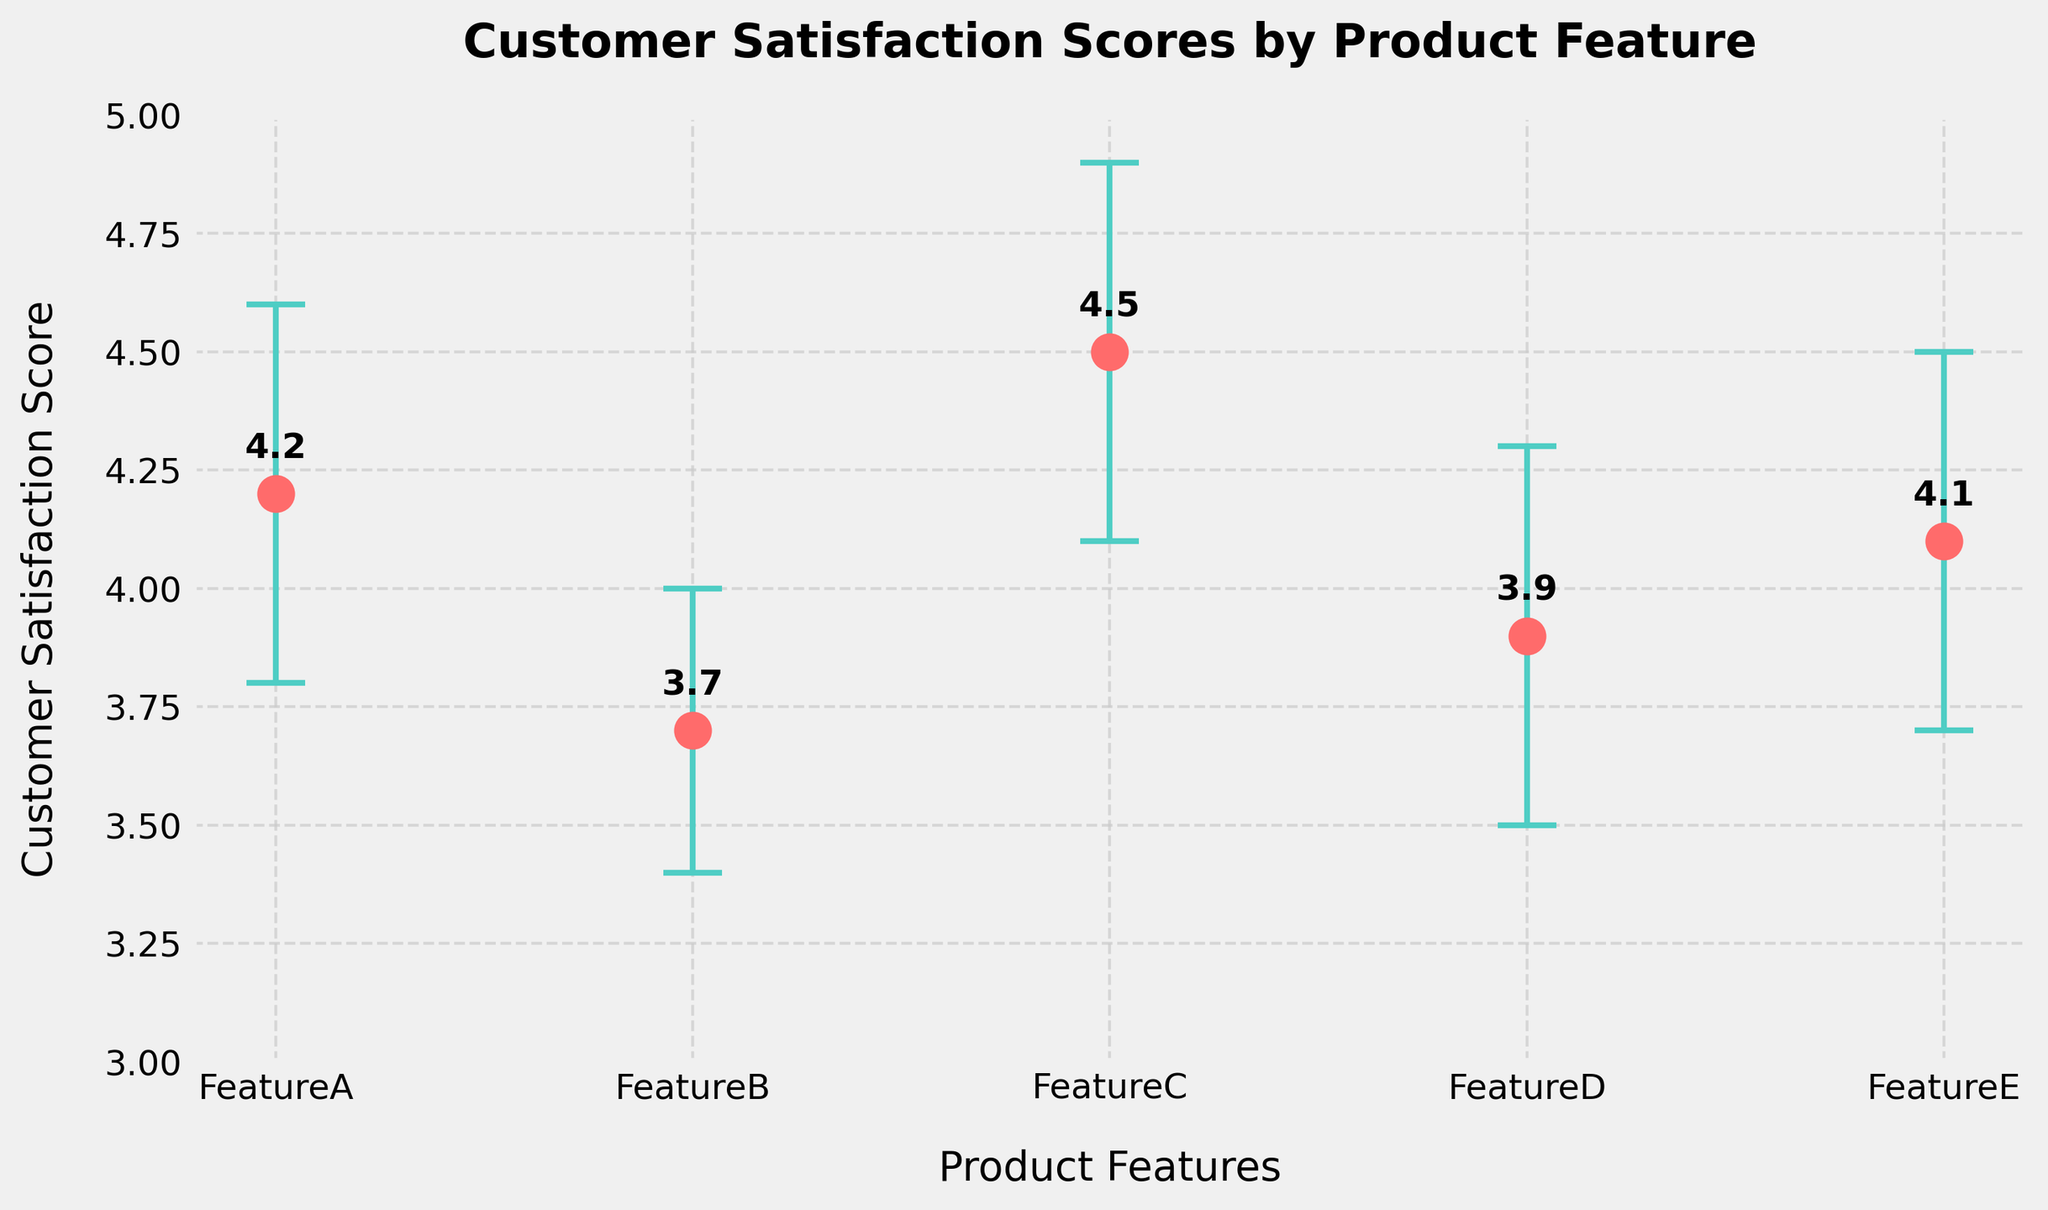What's the overall title of the figure? The overall title of the figure is displayed at the top of the plot, which encapsulates the main intention or subject matter of the plot. It appears in a bold font and clearly indicates what the plotted data is about. The title in the plot is "Customer Satisfaction Scores by Product Feature".
Answer: Customer Satisfaction Scores by Product Feature What are the x-axis labels in the plot? The x-axis of the plot lists the different product features being evaluated. Each label corresponds to a specific product feature for which customer satisfaction scores are measured. The labels on the x-axis are "FeatureA", "FeatureB", "FeatureC", "FeatureD", and "FeatureE".
Answer: FeatureA, FeatureB, FeatureC, FeatureD, FeatureE Which feature has the highest customer satisfaction score? To determine which feature has the highest customer satisfaction score, compare the values of the scores plotted for each feature. FeatureC has the highest value of 4.5 according to the plotted data.
Answer: FeatureC Which feature has the widest confidence interval? The width of the confidence interval can be determined by the difference between the upper and lower bounds of the interval (CI_Upper - CI_Lower). FeatureC has the widest interval (4.9 - 4.1) = 0.8.
Answer: FeatureC What is the customer satisfaction score for FeatureA? The plotted data points directly indicate the customer satisfaction score for each feature. For FeatureA, the data point shows a score of 4.2.
Answer: 4.2 Which features have scores with overlapping confidence intervals? To identify overlapping confidence intervals, compare the upper and lower bounds of the intervals for different features. FeatureA (3.8 to 4.6) overlaps with FeatureB (3.4 to 4.0), FeatureC (4.1 to 4.9) overlaps with FeatureA (3.8 to 4.6) and FeatureE (3.7 to 4.5).
Answer: FeatureA and FeatureB, FeatureA and FeatureC, FeatureC and FeatureE What is the range of customer satisfaction scores in the plot? The range is calculated by finding the difference between the highest and lowest customer satisfaction score values. The highest score is 4.5 (FeatureC) and the lowest score is 3.7 (FeatureB), thus the range is 4.5 - 3.7 = 0.8.
Answer: 0.8 Between which two features is the smallest difference in customer satisfaction score? Compare the differences between the customer satisfaction scores of various features. The smallest difference is between FeatureD (3.9) and FeatureB (3.7), which is 3.9 - 3.7 = 0.2.
Answer: FeatureD and FeatureB 